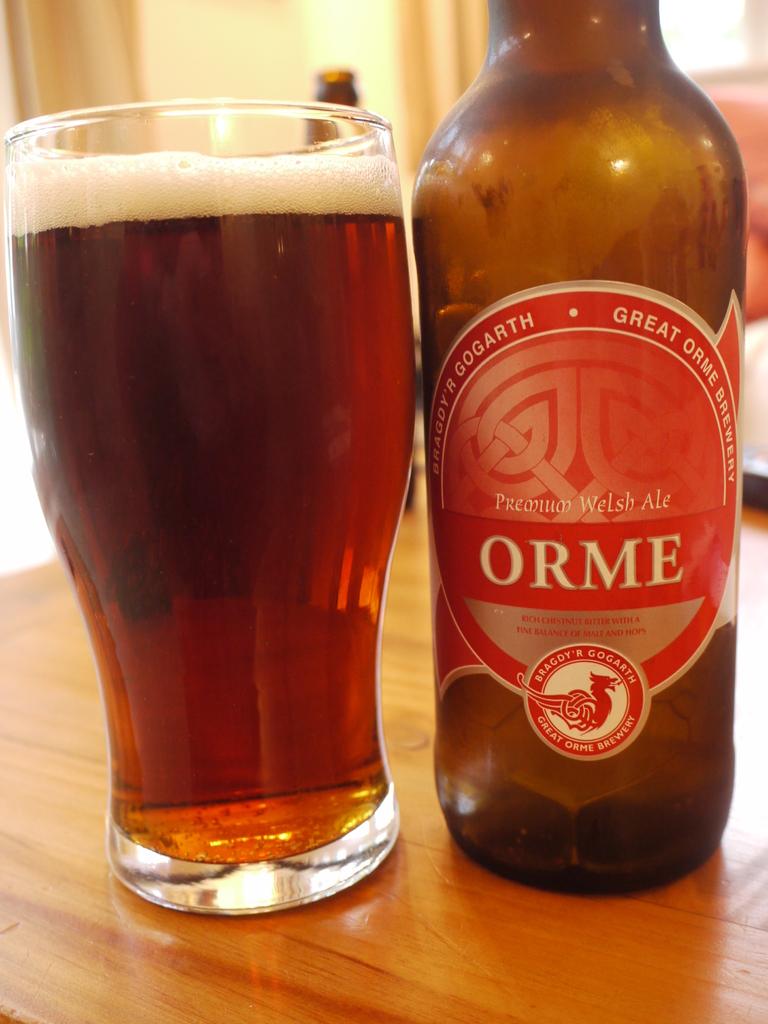Who makes this brand of beer?
Provide a short and direct response. Orme. What country is the ale?
Offer a very short reply. Welsh. 